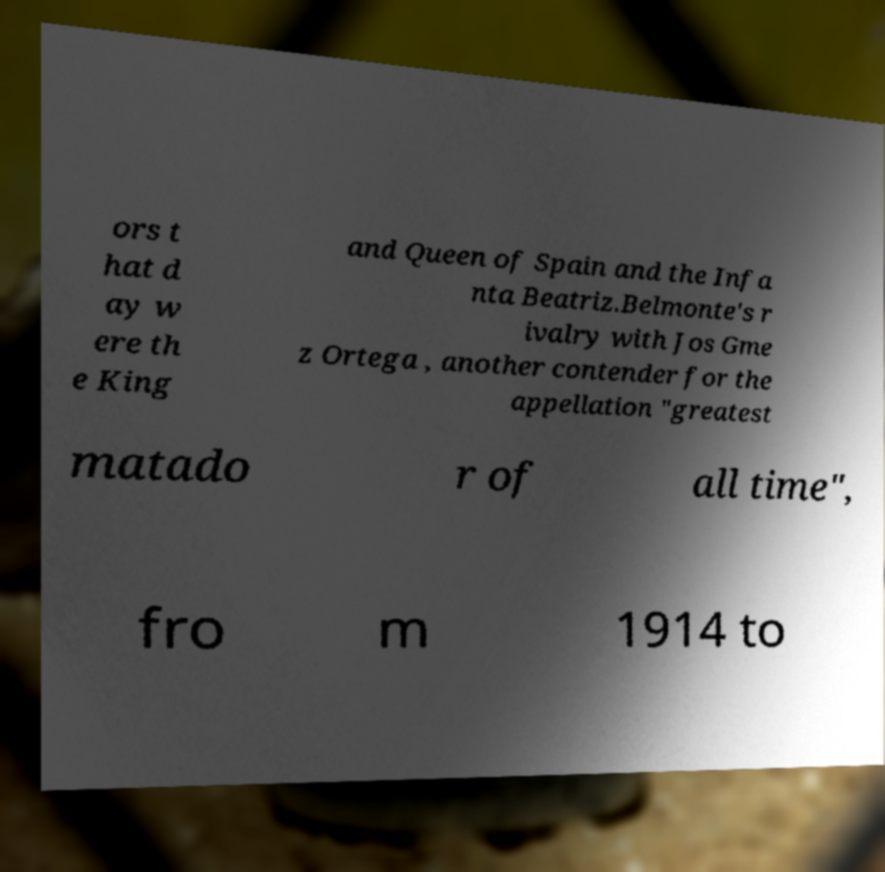For documentation purposes, I need the text within this image transcribed. Could you provide that? ors t hat d ay w ere th e King and Queen of Spain and the Infa nta Beatriz.Belmonte's r ivalry with Jos Gme z Ortega , another contender for the appellation "greatest matado r of all time", fro m 1914 to 